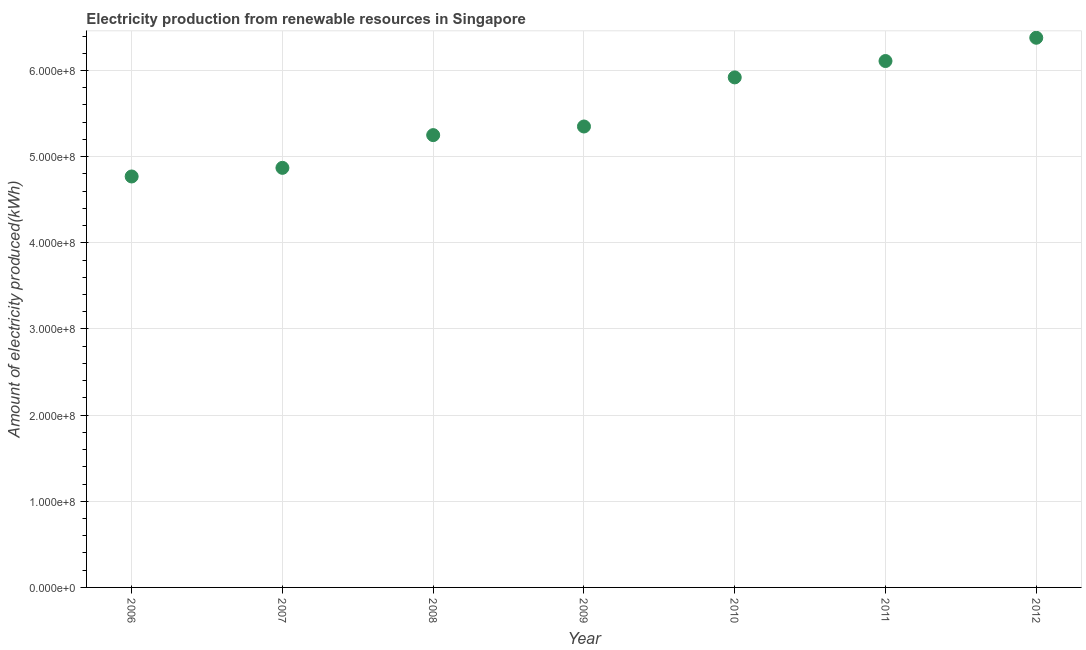What is the amount of electricity produced in 2011?
Provide a succinct answer. 6.11e+08. Across all years, what is the maximum amount of electricity produced?
Ensure brevity in your answer.  6.38e+08. Across all years, what is the minimum amount of electricity produced?
Keep it short and to the point. 4.77e+08. What is the sum of the amount of electricity produced?
Keep it short and to the point. 3.86e+09. What is the difference between the amount of electricity produced in 2007 and 2009?
Keep it short and to the point. -4.80e+07. What is the average amount of electricity produced per year?
Ensure brevity in your answer.  5.52e+08. What is the median amount of electricity produced?
Give a very brief answer. 5.35e+08. In how many years, is the amount of electricity produced greater than 260000000 kWh?
Provide a succinct answer. 7. What is the ratio of the amount of electricity produced in 2006 to that in 2009?
Ensure brevity in your answer.  0.89. Is the amount of electricity produced in 2007 less than that in 2012?
Give a very brief answer. Yes. What is the difference between the highest and the second highest amount of electricity produced?
Provide a short and direct response. 2.70e+07. What is the difference between the highest and the lowest amount of electricity produced?
Ensure brevity in your answer.  1.61e+08. How many dotlines are there?
Your answer should be compact. 1. How many years are there in the graph?
Your response must be concise. 7. What is the difference between two consecutive major ticks on the Y-axis?
Offer a very short reply. 1.00e+08. Does the graph contain any zero values?
Your answer should be compact. No. Does the graph contain grids?
Your answer should be compact. Yes. What is the title of the graph?
Your answer should be very brief. Electricity production from renewable resources in Singapore. What is the label or title of the X-axis?
Make the answer very short. Year. What is the label or title of the Y-axis?
Offer a terse response. Amount of electricity produced(kWh). What is the Amount of electricity produced(kWh) in 2006?
Offer a terse response. 4.77e+08. What is the Amount of electricity produced(kWh) in 2007?
Offer a terse response. 4.87e+08. What is the Amount of electricity produced(kWh) in 2008?
Offer a very short reply. 5.25e+08. What is the Amount of electricity produced(kWh) in 2009?
Provide a succinct answer. 5.35e+08. What is the Amount of electricity produced(kWh) in 2010?
Offer a very short reply. 5.92e+08. What is the Amount of electricity produced(kWh) in 2011?
Give a very brief answer. 6.11e+08. What is the Amount of electricity produced(kWh) in 2012?
Offer a very short reply. 6.38e+08. What is the difference between the Amount of electricity produced(kWh) in 2006 and 2007?
Keep it short and to the point. -1.00e+07. What is the difference between the Amount of electricity produced(kWh) in 2006 and 2008?
Provide a succinct answer. -4.80e+07. What is the difference between the Amount of electricity produced(kWh) in 2006 and 2009?
Your response must be concise. -5.80e+07. What is the difference between the Amount of electricity produced(kWh) in 2006 and 2010?
Your answer should be very brief. -1.15e+08. What is the difference between the Amount of electricity produced(kWh) in 2006 and 2011?
Your answer should be compact. -1.34e+08. What is the difference between the Amount of electricity produced(kWh) in 2006 and 2012?
Provide a succinct answer. -1.61e+08. What is the difference between the Amount of electricity produced(kWh) in 2007 and 2008?
Offer a terse response. -3.80e+07. What is the difference between the Amount of electricity produced(kWh) in 2007 and 2009?
Your response must be concise. -4.80e+07. What is the difference between the Amount of electricity produced(kWh) in 2007 and 2010?
Offer a very short reply. -1.05e+08. What is the difference between the Amount of electricity produced(kWh) in 2007 and 2011?
Provide a short and direct response. -1.24e+08. What is the difference between the Amount of electricity produced(kWh) in 2007 and 2012?
Ensure brevity in your answer.  -1.51e+08. What is the difference between the Amount of electricity produced(kWh) in 2008 and 2009?
Ensure brevity in your answer.  -1.00e+07. What is the difference between the Amount of electricity produced(kWh) in 2008 and 2010?
Make the answer very short. -6.70e+07. What is the difference between the Amount of electricity produced(kWh) in 2008 and 2011?
Provide a short and direct response. -8.60e+07. What is the difference between the Amount of electricity produced(kWh) in 2008 and 2012?
Offer a very short reply. -1.13e+08. What is the difference between the Amount of electricity produced(kWh) in 2009 and 2010?
Provide a short and direct response. -5.70e+07. What is the difference between the Amount of electricity produced(kWh) in 2009 and 2011?
Make the answer very short. -7.60e+07. What is the difference between the Amount of electricity produced(kWh) in 2009 and 2012?
Offer a terse response. -1.03e+08. What is the difference between the Amount of electricity produced(kWh) in 2010 and 2011?
Make the answer very short. -1.90e+07. What is the difference between the Amount of electricity produced(kWh) in 2010 and 2012?
Offer a terse response. -4.60e+07. What is the difference between the Amount of electricity produced(kWh) in 2011 and 2012?
Provide a short and direct response. -2.70e+07. What is the ratio of the Amount of electricity produced(kWh) in 2006 to that in 2008?
Your answer should be very brief. 0.91. What is the ratio of the Amount of electricity produced(kWh) in 2006 to that in 2009?
Your answer should be compact. 0.89. What is the ratio of the Amount of electricity produced(kWh) in 2006 to that in 2010?
Offer a very short reply. 0.81. What is the ratio of the Amount of electricity produced(kWh) in 2006 to that in 2011?
Provide a short and direct response. 0.78. What is the ratio of the Amount of electricity produced(kWh) in 2006 to that in 2012?
Provide a short and direct response. 0.75. What is the ratio of the Amount of electricity produced(kWh) in 2007 to that in 2008?
Your answer should be compact. 0.93. What is the ratio of the Amount of electricity produced(kWh) in 2007 to that in 2009?
Your answer should be very brief. 0.91. What is the ratio of the Amount of electricity produced(kWh) in 2007 to that in 2010?
Give a very brief answer. 0.82. What is the ratio of the Amount of electricity produced(kWh) in 2007 to that in 2011?
Your response must be concise. 0.8. What is the ratio of the Amount of electricity produced(kWh) in 2007 to that in 2012?
Ensure brevity in your answer.  0.76. What is the ratio of the Amount of electricity produced(kWh) in 2008 to that in 2010?
Ensure brevity in your answer.  0.89. What is the ratio of the Amount of electricity produced(kWh) in 2008 to that in 2011?
Offer a very short reply. 0.86. What is the ratio of the Amount of electricity produced(kWh) in 2008 to that in 2012?
Offer a terse response. 0.82. What is the ratio of the Amount of electricity produced(kWh) in 2009 to that in 2010?
Offer a terse response. 0.9. What is the ratio of the Amount of electricity produced(kWh) in 2009 to that in 2011?
Ensure brevity in your answer.  0.88. What is the ratio of the Amount of electricity produced(kWh) in 2009 to that in 2012?
Your answer should be compact. 0.84. What is the ratio of the Amount of electricity produced(kWh) in 2010 to that in 2011?
Make the answer very short. 0.97. What is the ratio of the Amount of electricity produced(kWh) in 2010 to that in 2012?
Provide a short and direct response. 0.93. What is the ratio of the Amount of electricity produced(kWh) in 2011 to that in 2012?
Provide a short and direct response. 0.96. 